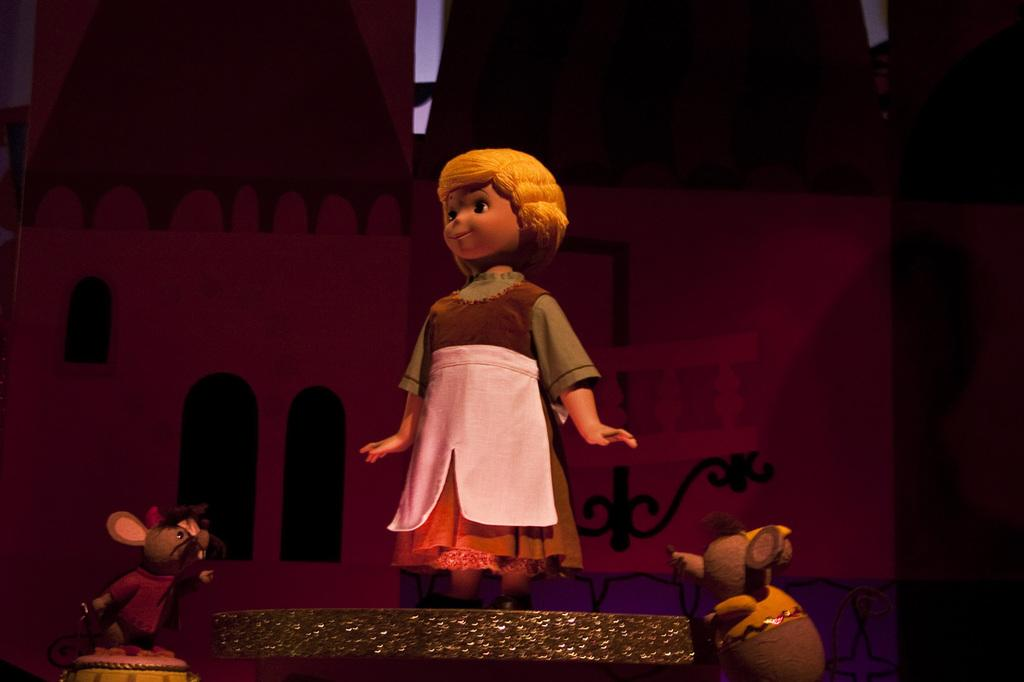What type of objects can be seen in the image? There are dolls present in the image. Can you describe the dolls in the image? Unfortunately, the provided facts do not include any details about the dolls. Are there any other objects or figures in the image besides the dolls? The provided facts do not mention any other objects or figures in the image. What type of lunch is being served in the aftermath of the event depicted in the image? There is no event or lunch depicted in the image, as it only features dolls. 